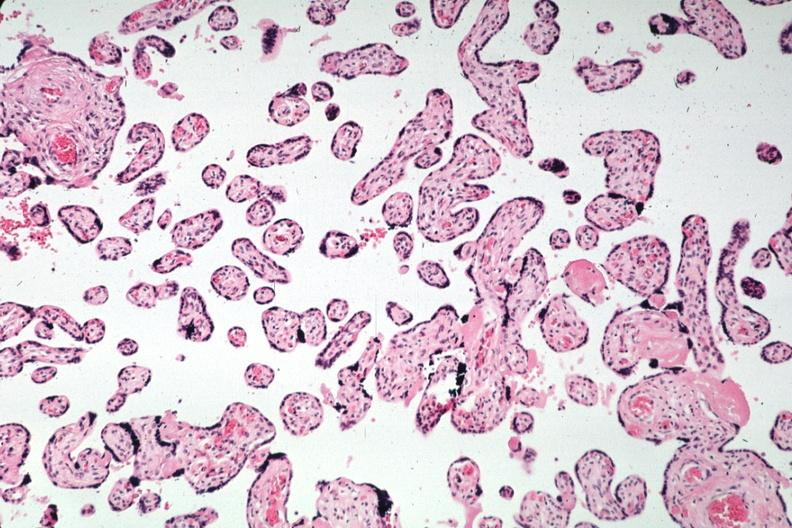where is this from?
Answer the question using a single word or phrase. Female reproductive system 